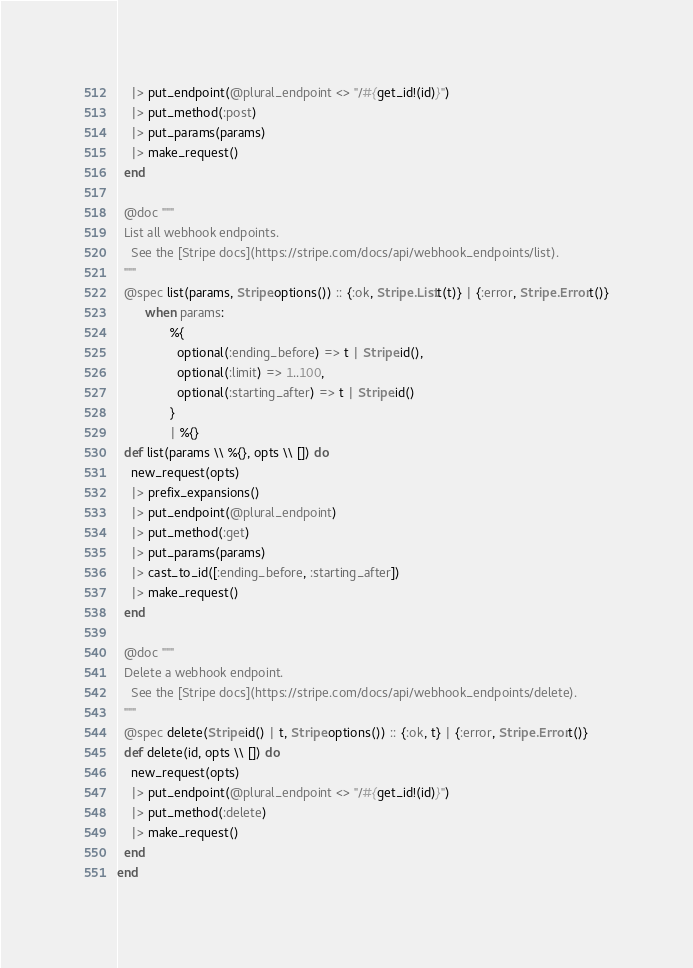Convert code to text. <code><loc_0><loc_0><loc_500><loc_500><_Elixir_>    |> put_endpoint(@plural_endpoint <> "/#{get_id!(id)}")
    |> put_method(:post)
    |> put_params(params)
    |> make_request()
  end

  @doc """
  List all webhook endpoints.
    See the [Stripe docs](https://stripe.com/docs/api/webhook_endpoints/list).
  """
  @spec list(params, Stripe.options()) :: {:ok, Stripe.List.t(t)} | {:error, Stripe.Error.t()}
        when params:
               %{
                 optional(:ending_before) => t | Stripe.id(),
                 optional(:limit) => 1..100,
                 optional(:starting_after) => t | Stripe.id()
               }
               | %{}
  def list(params \\ %{}, opts \\ []) do
    new_request(opts)
    |> prefix_expansions()
    |> put_endpoint(@plural_endpoint)
    |> put_method(:get)
    |> put_params(params)
    |> cast_to_id([:ending_before, :starting_after])
    |> make_request()
  end

  @doc """
  Delete a webhook endpoint.
    See the [Stripe docs](https://stripe.com/docs/api/webhook_endpoints/delete).
  """
  @spec delete(Stripe.id() | t, Stripe.options()) :: {:ok, t} | {:error, Stripe.Error.t()}
  def delete(id, opts \\ []) do
    new_request(opts)
    |> put_endpoint(@plural_endpoint <> "/#{get_id!(id)}")
    |> put_method(:delete)
    |> make_request()
  end
end
</code> 